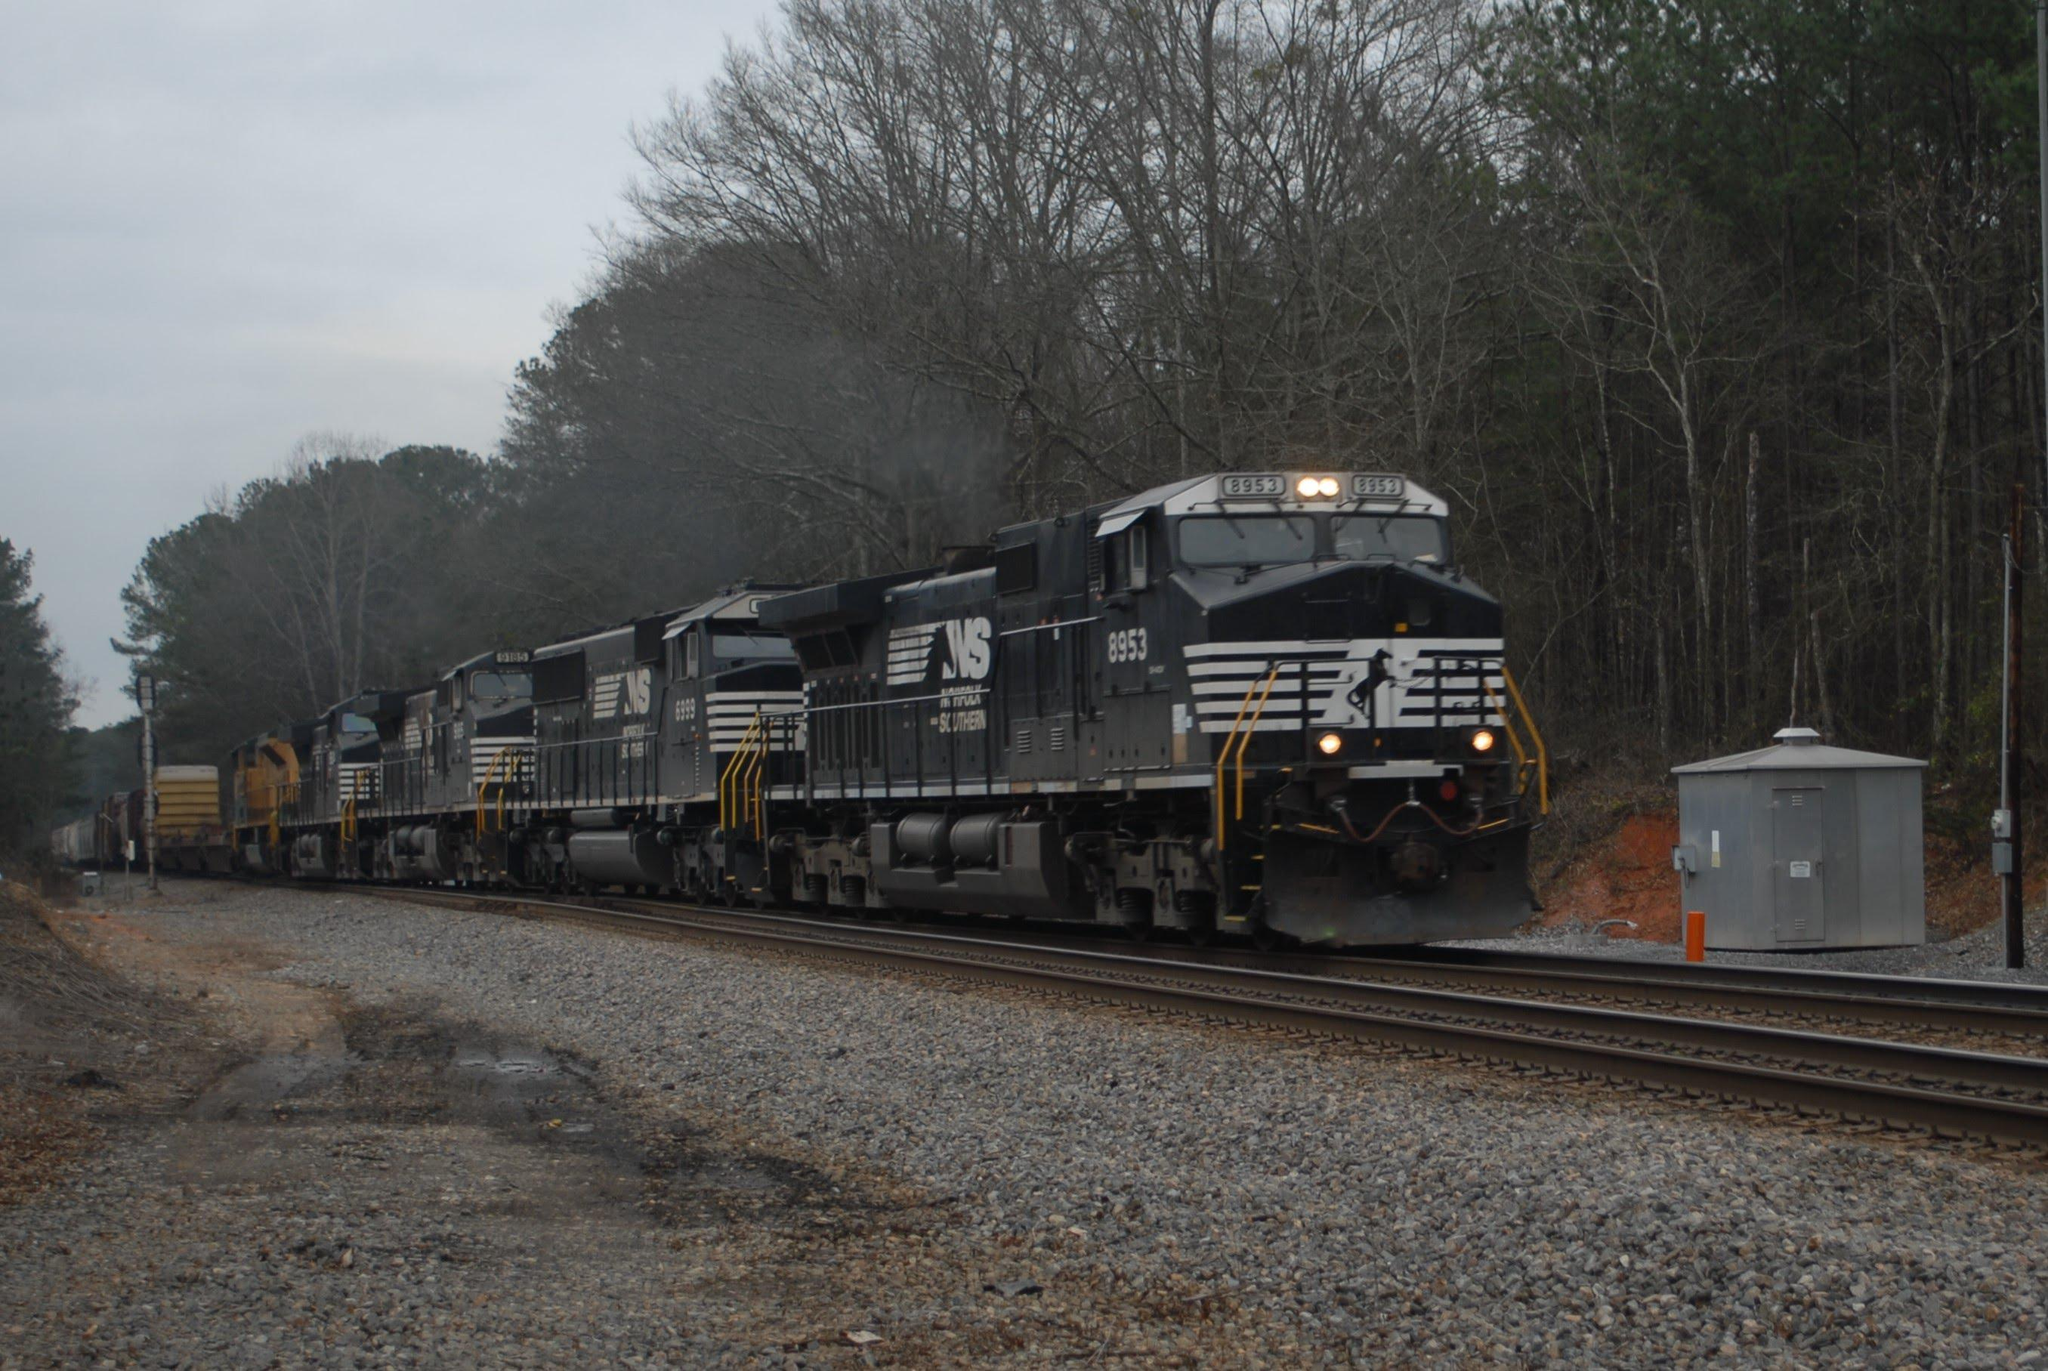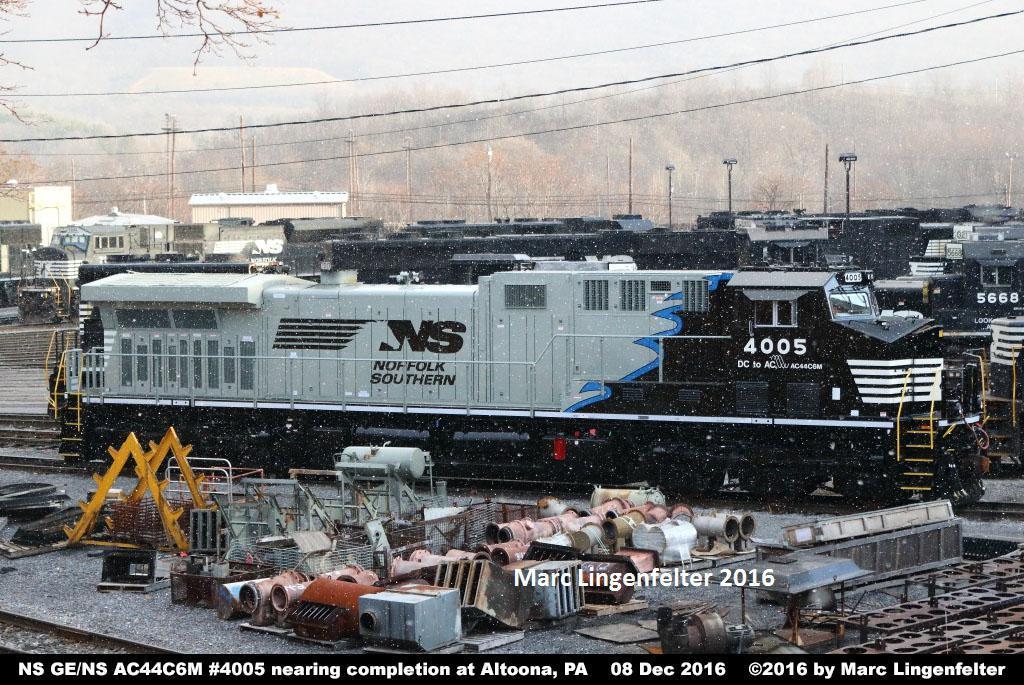The first image is the image on the left, the second image is the image on the right. Examine the images to the left and right. Is the description "A train has a bright yellow front and faces leftward." accurate? Answer yes or no. No. The first image is the image on the left, the second image is the image on the right. Considering the images on both sides, is "The left image contains a train that is headed towards the right." valid? Answer yes or no. Yes. 